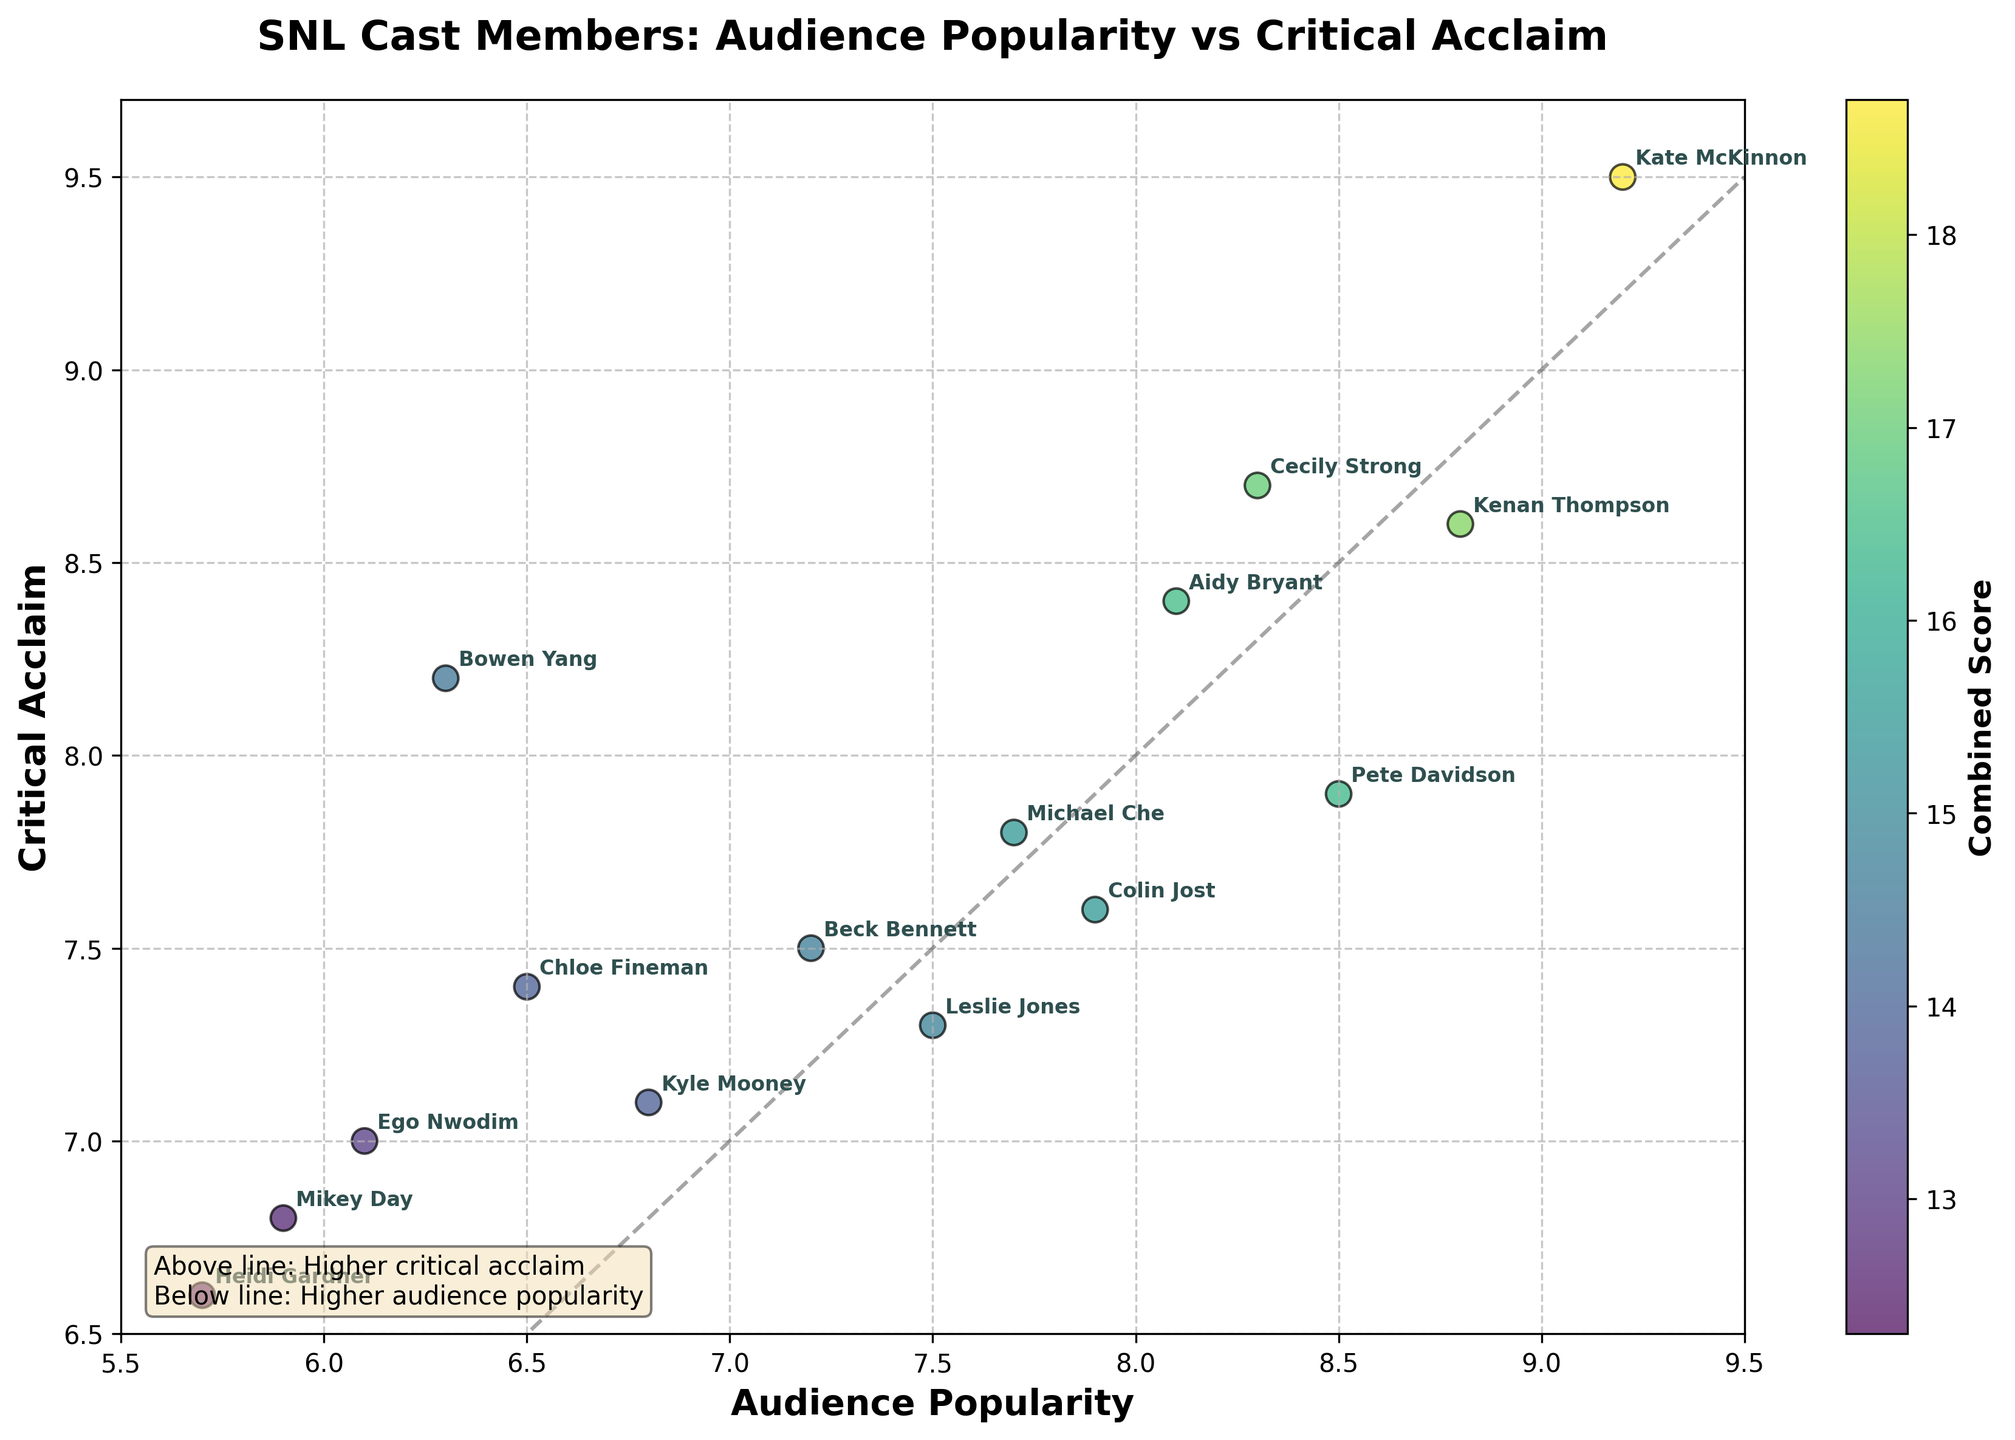How many data points are there in the figure? To find the number of data points, count the individual cast member names labeled on the plot.
Answer: 15 What is the title of the biplot? The title is at the top of the figure, describing what the plot represents.
Answer: SNL Cast Members: Audience Popularity vs Critical Acclaim Which cast member has the highest audience popularity? Find the cast member label located highest on the x-axis, as the x-axis represents audience popularity.
Answer: Kate McKinnon Who are the top three cast members in terms of critical acclaim? Look at the y-axis to find the cast members with the highest critical acclaim scores. The top three are those with labels closest to the highest y-values.
Answer: Kate McKinnon, Cecily Strong, Bowen Yang Which cast member has higher audience popularity, Kate McKinnon or Kenan Thompson? Compare the x-axis position of Kate McKinnon and Kenan Thompson; the one further to the right has higher audience popularity.
Answer: Kate McKinnon Who has a higher combined score, Pete Davidson or Michael Che? Add the audience popularity and critical acclaim scores for both members, then compare the sums. Pete Davidson: 8.5 + 7.9 = 16.4, Michael Che: 7.7 + 7.8 = 15.5.
Answer: Pete Davidson Which cast members fall below the diagonal line indicating higher audience popularity than critical acclaim? Identify the cast members who are positioned below the line that runs diagonally from the bottom-left to the top-right of the plot.
Answer: Pete Davidson, Cecily Strong, Leslie Jones, Heidi Gardner What does the color of the scatter points represent? Look at the color bar next to the plot, which indicates what the color gradient represents.
Answer: Combined Score Which cast member is closest to having equal audience popularity and critical acclaim? Find the cast member closest to the diagonal line, indicating equal audience popularity and critical acclaim.
Answer: Aidy Bryant 